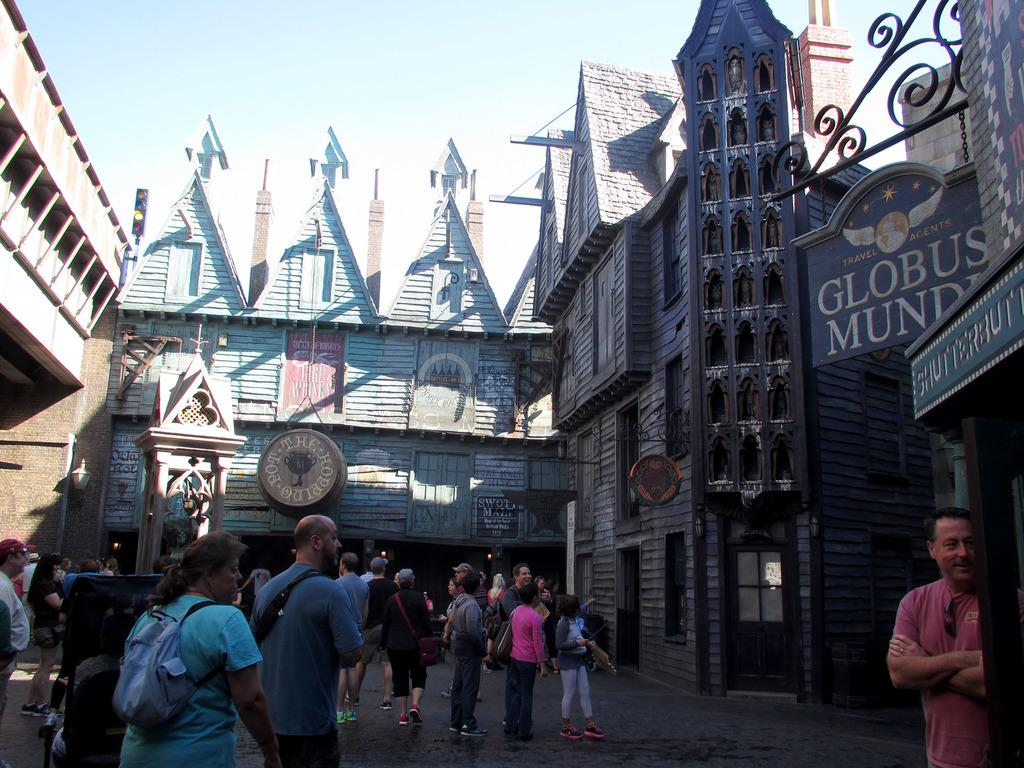What are the people in the image doing? There is a group of people standing and waiting in the image. What can be seen in the background of the image? There is a wooden building with an arch in the background. What is the structure on the right side of the image? There is a glass door on the right side of the image. Where is the girl located in the image? The girl is visible on the top of the image. What type of joke can be seen on the faucet in the image? There is no faucet present in the image, so no joke can be seen on it. 